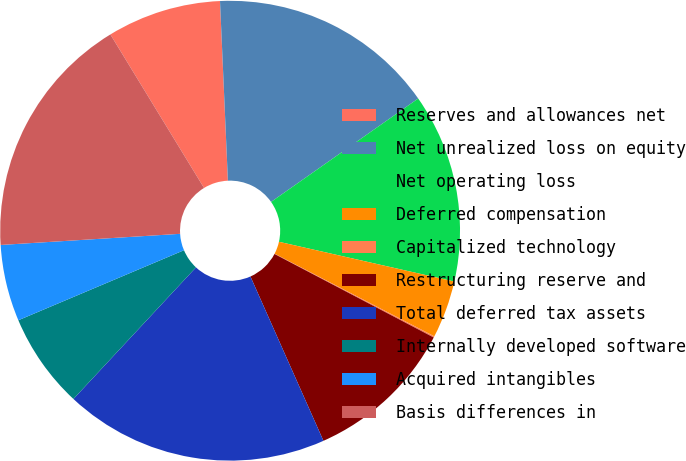Convert chart. <chart><loc_0><loc_0><loc_500><loc_500><pie_chart><fcel>Reserves and allowances net<fcel>Net unrealized loss on equity<fcel>Net operating loss<fcel>Deferred compensation<fcel>Capitalized technology<fcel>Restructuring reserve and<fcel>Total deferred tax assets<fcel>Internally developed software<fcel>Acquired intangibles<fcel>Basis differences in<nl><fcel>8.02%<fcel>15.95%<fcel>13.3%<fcel>4.05%<fcel>0.09%<fcel>10.66%<fcel>18.59%<fcel>6.7%<fcel>5.38%<fcel>17.27%<nl></chart> 